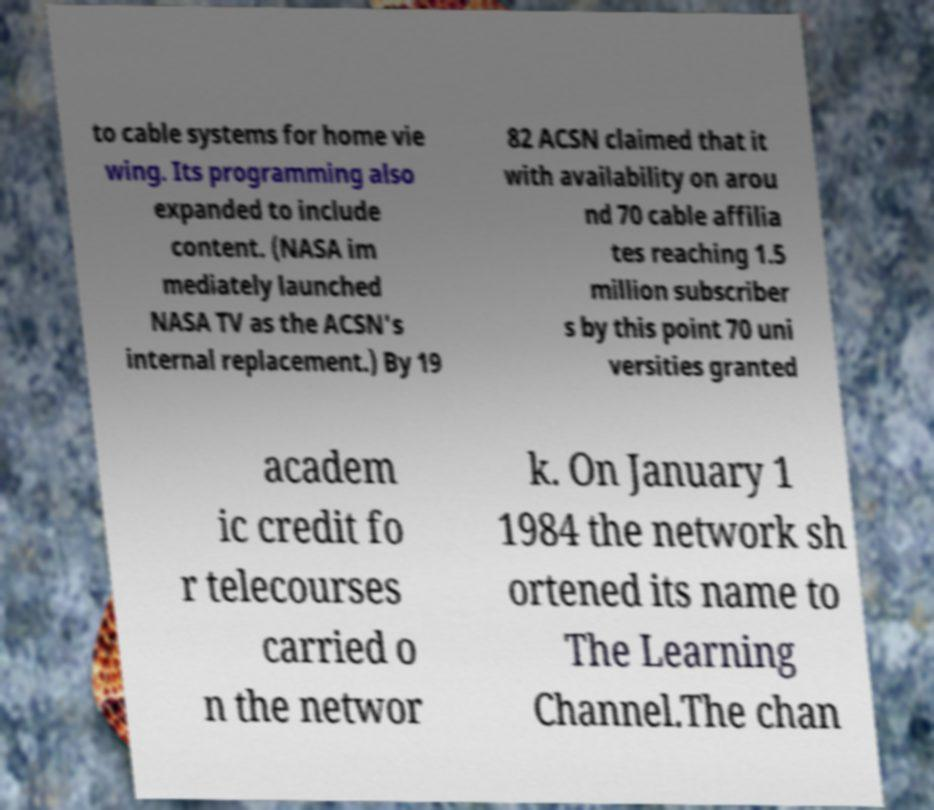Please identify and transcribe the text found in this image. to cable systems for home vie wing. Its programming also expanded to include content. (NASA im mediately launched NASA TV as the ACSN's internal replacement.) By 19 82 ACSN claimed that it with availability on arou nd 70 cable affilia tes reaching 1.5 million subscriber s by this point 70 uni versities granted academ ic credit fo r telecourses carried o n the networ k. On January 1 1984 the network sh ortened its name to The Learning Channel.The chan 